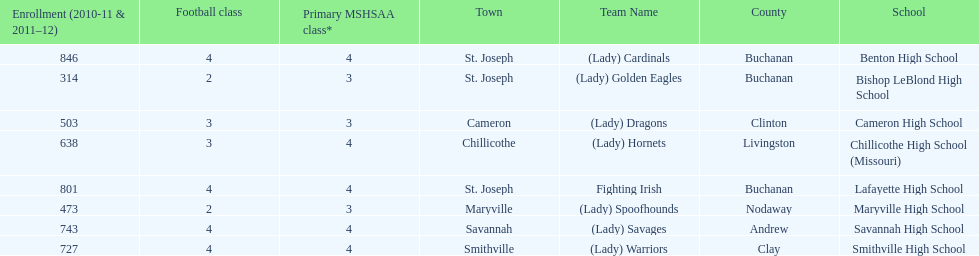Benton high school and bishop leblond high school are both located in what town? St. Joseph. 